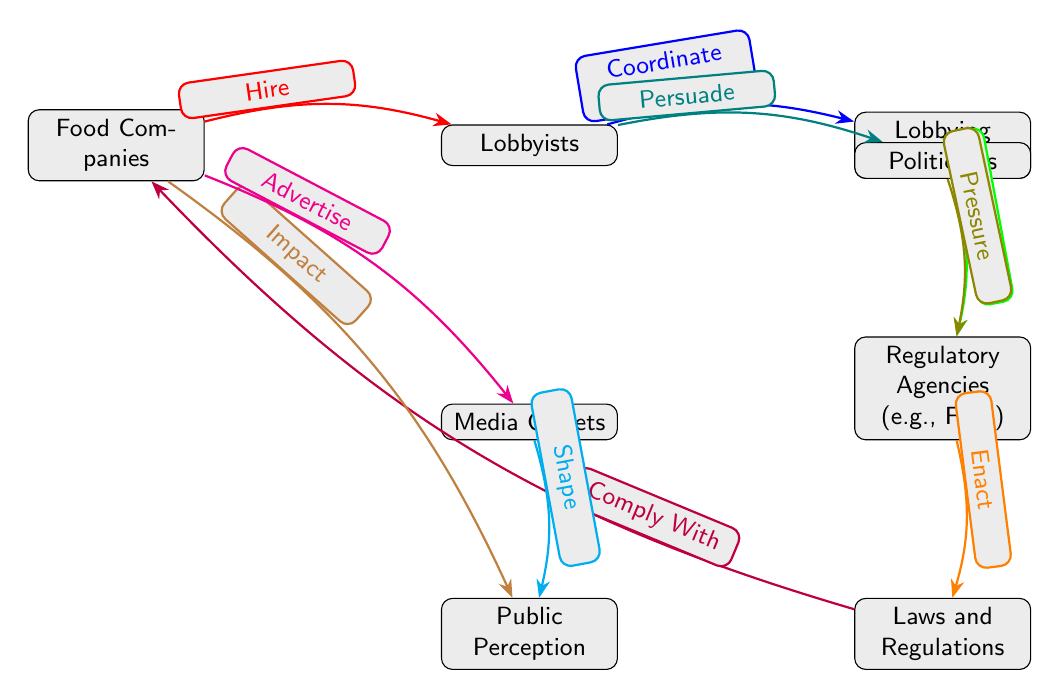What are the two entities directly connected to Food Companies? From the diagram, Food Companies are directly connected to Lobbyists and Laws and Regulations. The diagram shows edges leading from Food Companies to both nodes.
Answer: Lobbyists and Laws and Regulations How many nodes are in the diagram? The diagram includes eight nodes: Food Companies, Lobbyists, Lobbying Firms, Regulatory Agencies, Laws and Regulations, Public Perception, Media Outlets, and Politicians. Counting each one gives a total of eight.
Answer: Eight What role does Lobbyists play in relation to Politicians? The diagram indicates that Lobbyists "Persuade" Politicians. An edge directed from Lobbyists to Politicians shows this relationship.
Answer: Persuade Which node has the edge connecting to Media Outlets? The diagram reveals that Food Companies have an edge saying "Advertise" that connects to Media Outlets, indicating their relationship.
Answer: Food Companies What is the nature of the relationship between Lobbying Firms and Regulatory Agencies? The diagram states that Lobbying Firms "Influence" Regulatory Agencies, as indicated by the directed edge connecting these nodes in that direction.
Answer: Influence How many edges are there in total in the diagram? The diagram depicts seven edges connecting the nodes, illustrating the various interactions. Counting each of the arrows gives a total of seven.
Answer: Seven What impact do Food Companies have on Public Perception? The diagram indicates that Food Companies "Impact" Public Perception through a direct edge, illustrating a direct influence of Food Companies on how the public perceives issues.
Answer: Impact What action do Regulatory Agencies take after lobbying efforts? According to the diagram, Regulatory Agencies "Enact" Laws and Regulations after being influenced by Lobbying Firms. This is shown by the directed edge from Regulatory Agencies to Laws and Regulations.
Answer: Enact What do Media Outlets do concerning Public Perception? The diagram states Media Outlets "Shape" Public Perception, indicating their role in influencing how the public views topics related to the food industry.
Answer: Shape 